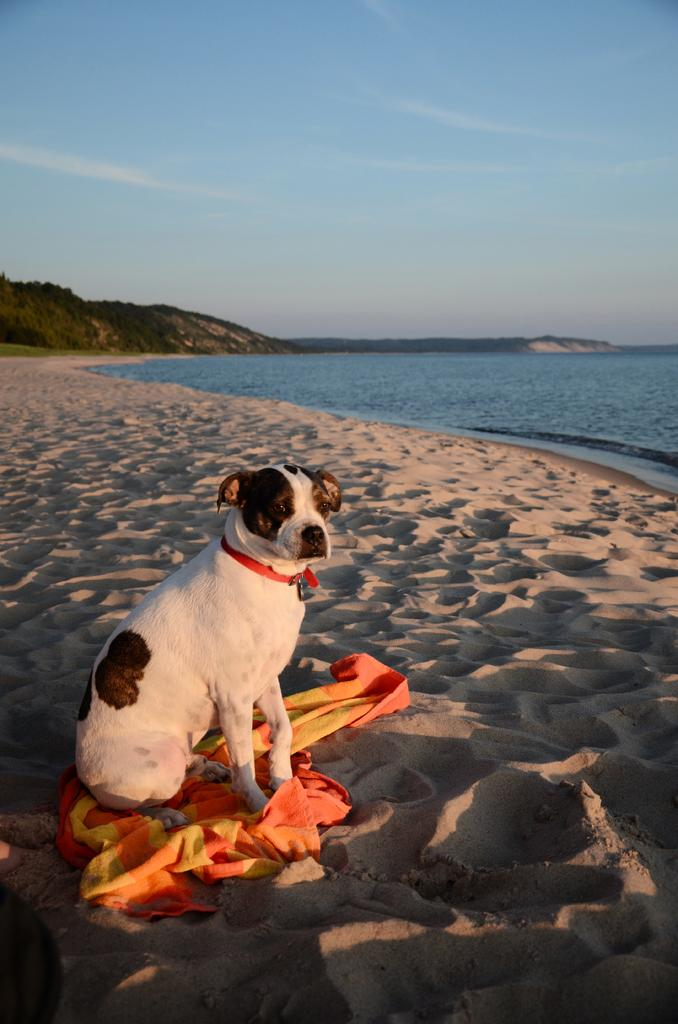What animal can be seen in the image? There is a dog in the image. Where is the dog located? The dog is sitting on the sand. What does the dog have with it? The dog has a cloth. What body of water is near the dog? The dog is beside a river with blue water. What type of vegetation is visible in the background? There are trees in the background of the image. What geographical feature is visible in the background? There are mountains in the background of the image. What is the color of the sky in the image? The sky is blue. What type of record is the dog playing on the instrument in the image? There is no record or instrument present in the image; it features a dog sitting on the sand with a cloth. What type of school is visible in the background of the image? There is no school visible in the image; it features a dog sitting on the sand beside a river with blue water, trees, mountains, and a blue sky in the background. 